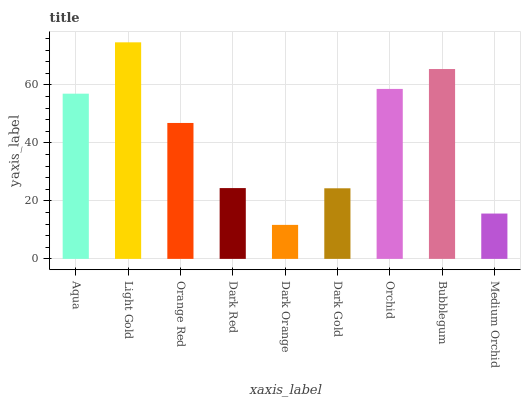Is Dark Orange the minimum?
Answer yes or no. Yes. Is Light Gold the maximum?
Answer yes or no. Yes. Is Orange Red the minimum?
Answer yes or no. No. Is Orange Red the maximum?
Answer yes or no. No. Is Light Gold greater than Orange Red?
Answer yes or no. Yes. Is Orange Red less than Light Gold?
Answer yes or no. Yes. Is Orange Red greater than Light Gold?
Answer yes or no. No. Is Light Gold less than Orange Red?
Answer yes or no. No. Is Orange Red the high median?
Answer yes or no. Yes. Is Orange Red the low median?
Answer yes or no. Yes. Is Dark Gold the high median?
Answer yes or no. No. Is Bubblegum the low median?
Answer yes or no. No. 